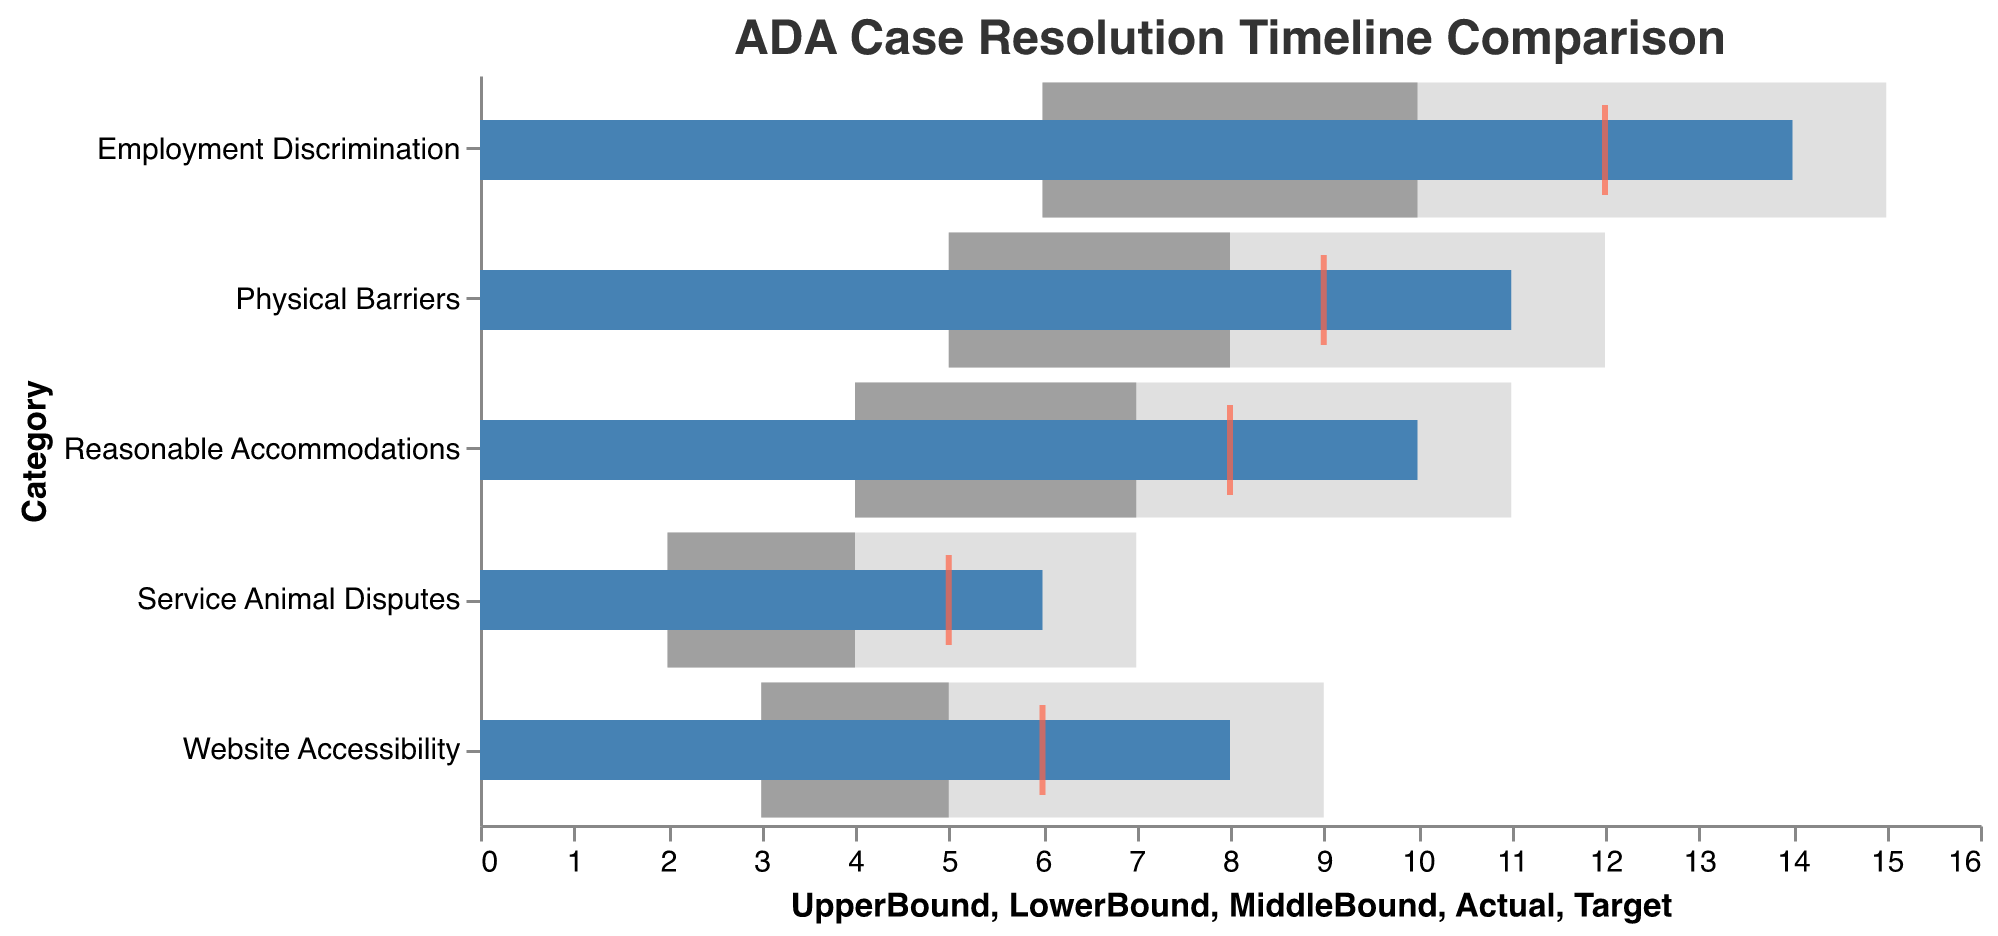What is the title of the bullet chart? The title of the chart is usually displayed at the top or in a prominent position and summarizes its main purpose. In this case, it directly states the comparison focus of the chart.
Answer: ADA Case Resolution Timeline Comparison What color represents the "Actual" resolution time in the chart? The "Actual" resolution time is indicated by a specific color for easy identification. According to the visual elements, this color is blue.
Answer: Blue Which category has the highest "Actual" resolution time? By looking at the blue bars that represent the "Actual" times, the longest bar indicates the highest resolution time. Employment Discrimination has the highest.
Answer: Employment Discrimination What is the target resolution time for "Website Accessibility" cases? The target resolution time is represented by red ticks. For Website Accessibility, the red tick indicates the target.
Answer: 6 months How much longer did it take to resolve Employment Discrimination cases compared to their target time? Subtract the "Target" time from the "Actual" time for Employment Discrimination cases. 14 (Actual) - 12 (Target) = 2 months longer.
Answer: 2 months Which category's actual resolution time falls within the upper bound but above the middle bound? Look for blue bars that end between the middle and upper bound ranges. Both Employment Discrimination and Reasonable Accommodations fall into this range.
Answer: Employment Discrimination, Reasonable Accommodations For which category are the "Actual" and "Target" resolution times equal? Compare the positions of the blue bar (Actual) and the red tick (Target). Service Animal Disputes has these values equal.
Answer: Service Animal Disputes How do the "Actual" and "LowerBound" resolution times compare for Physical Barriers cases? Subtract the lower bound from the actual time for Physical Barriers. 11 (Actual) - 5 (LowerBound) = 6 months longer than the lower bound.
Answer: 6 months longer Which category has the smallest difference between "Actual" and "Target" resolution times? For each category, subtract the "Target" from the "Actual" time and find the smallest difference. Service Animal Disputes has a difference of 1 month, which is the smallest.
Answer: Service Animal Disputes On average, how much longer than the target do the cases take across all categories? For each category, calculate the difference between "Actual" and "Target". Add these differences and divide by the number of categories: ((14-12) + (8-6) + (11-9) + (6-5) + (10-8)) / 5 = (2 + 2 + 2 + 1 + 2) / 5 = 9 / 5 = 1.8 months.
Answer: 1.8 months 